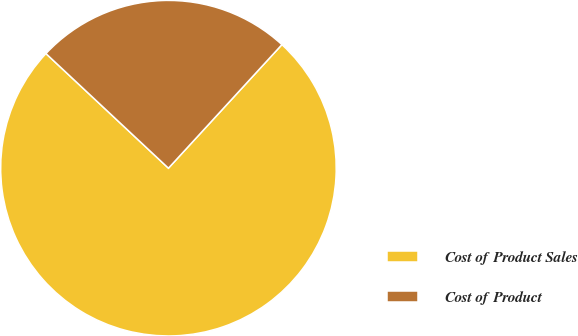Convert chart. <chart><loc_0><loc_0><loc_500><loc_500><pie_chart><fcel>Cost of Product Sales<fcel>Cost of Product<nl><fcel>75.15%<fcel>24.85%<nl></chart> 